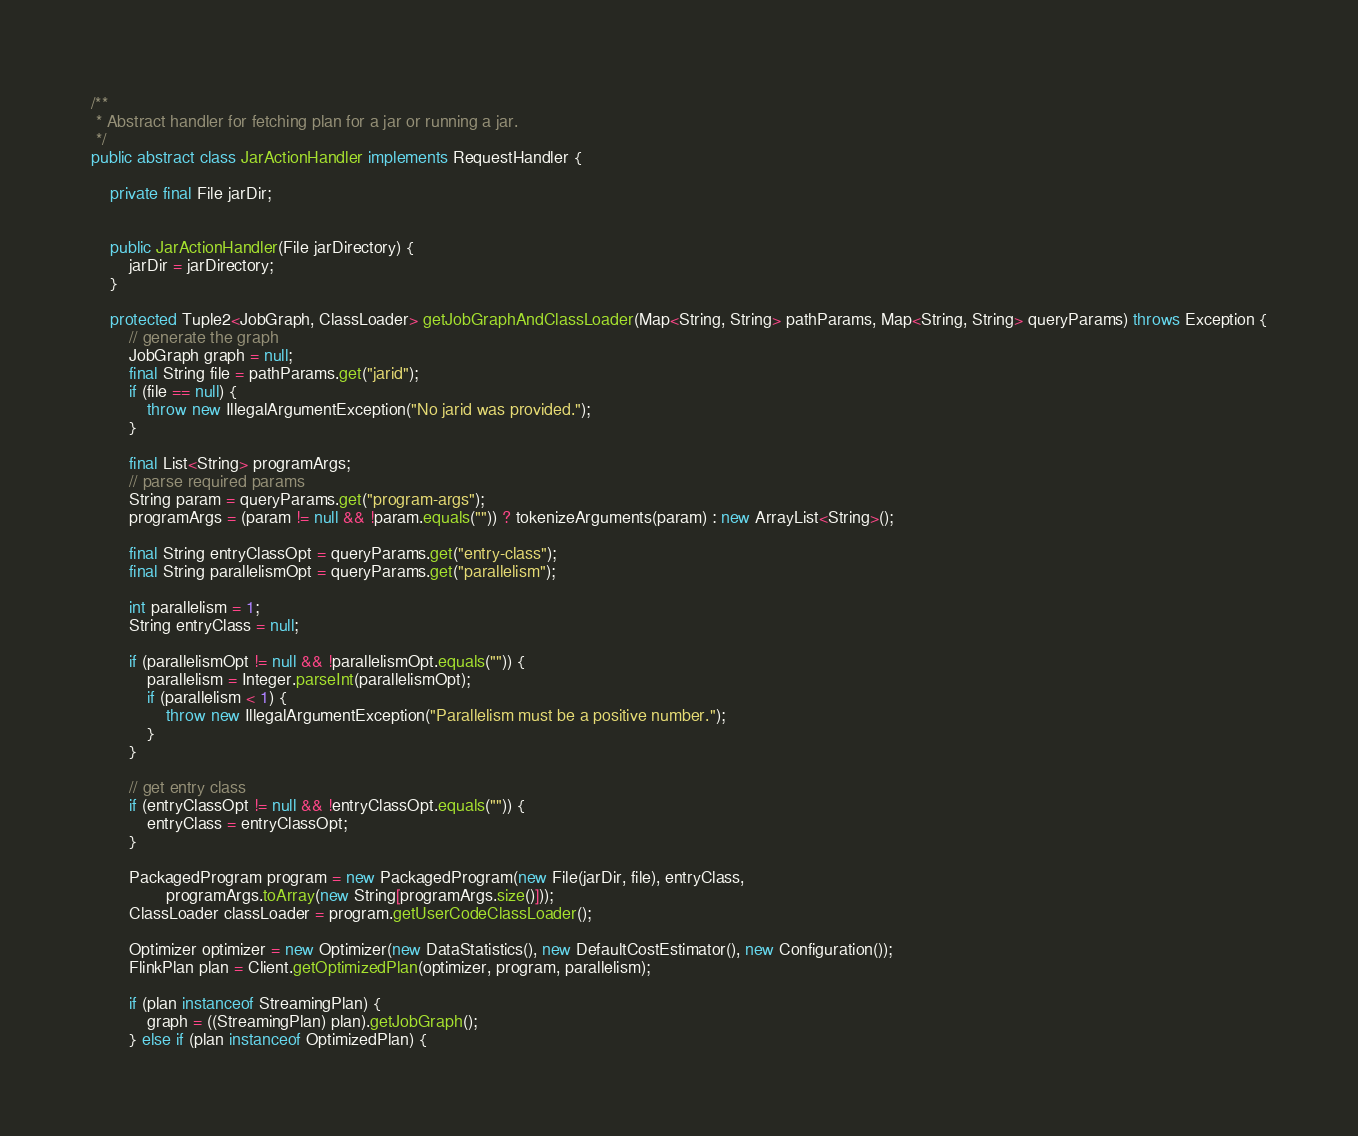Convert code to text. <code><loc_0><loc_0><loc_500><loc_500><_Java_>/**
 * Abstract handler for fetching plan for a jar or running a jar.
 */
public abstract class JarActionHandler implements RequestHandler {
	
	private final File jarDir;

	
	public JarActionHandler(File jarDirectory) {
		jarDir = jarDirectory;
	}

	protected Tuple2<JobGraph, ClassLoader> getJobGraphAndClassLoader(Map<String, String> pathParams, Map<String, String> queryParams) throws Exception {
		// generate the graph
		JobGraph graph = null;
		final String file = pathParams.get("jarid");
		if (file == null) {
			throw new IllegalArgumentException("No jarid was provided.");
		}

		final List<String> programArgs;
		// parse required params
		String param = queryParams.get("program-args");
		programArgs = (param != null && !param.equals("")) ? tokenizeArguments(param) : new ArrayList<String>();

		final String entryClassOpt = queryParams.get("entry-class");
		final String parallelismOpt = queryParams.get("parallelism");

		int parallelism = 1;
		String entryClass = null;

		if (parallelismOpt != null && !parallelismOpt.equals("")) {
			parallelism = Integer.parseInt(parallelismOpt);
			if (parallelism < 1) {
				throw new IllegalArgumentException("Parallelism must be a positive number.");
			}
		}

		// get entry class
		if (entryClassOpt != null && !entryClassOpt.equals("")) {
			entryClass = entryClassOpt;
		}

		PackagedProgram program = new PackagedProgram(new File(jarDir, file), entryClass,
				programArgs.toArray(new String[programArgs.size()]));
		ClassLoader classLoader = program.getUserCodeClassLoader();

		Optimizer optimizer = new Optimizer(new DataStatistics(), new DefaultCostEstimator(), new Configuration());
		FlinkPlan plan = Client.getOptimizedPlan(optimizer, program, parallelism);

		if (plan instanceof StreamingPlan) {
			graph = ((StreamingPlan) plan).getJobGraph();
		} else if (plan instanceof OptimizedPlan) {</code> 